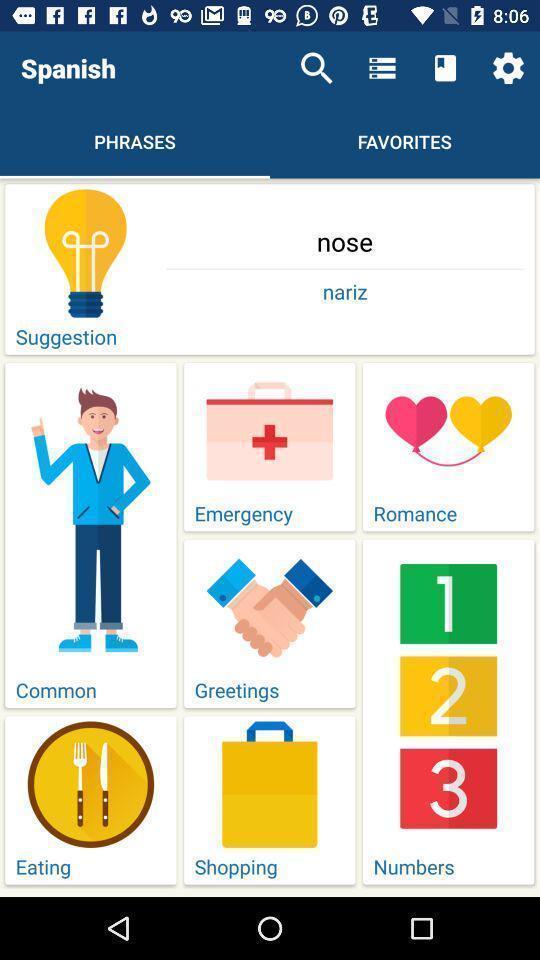Summarize the main components in this picture. Phrases of nose in spanish. 